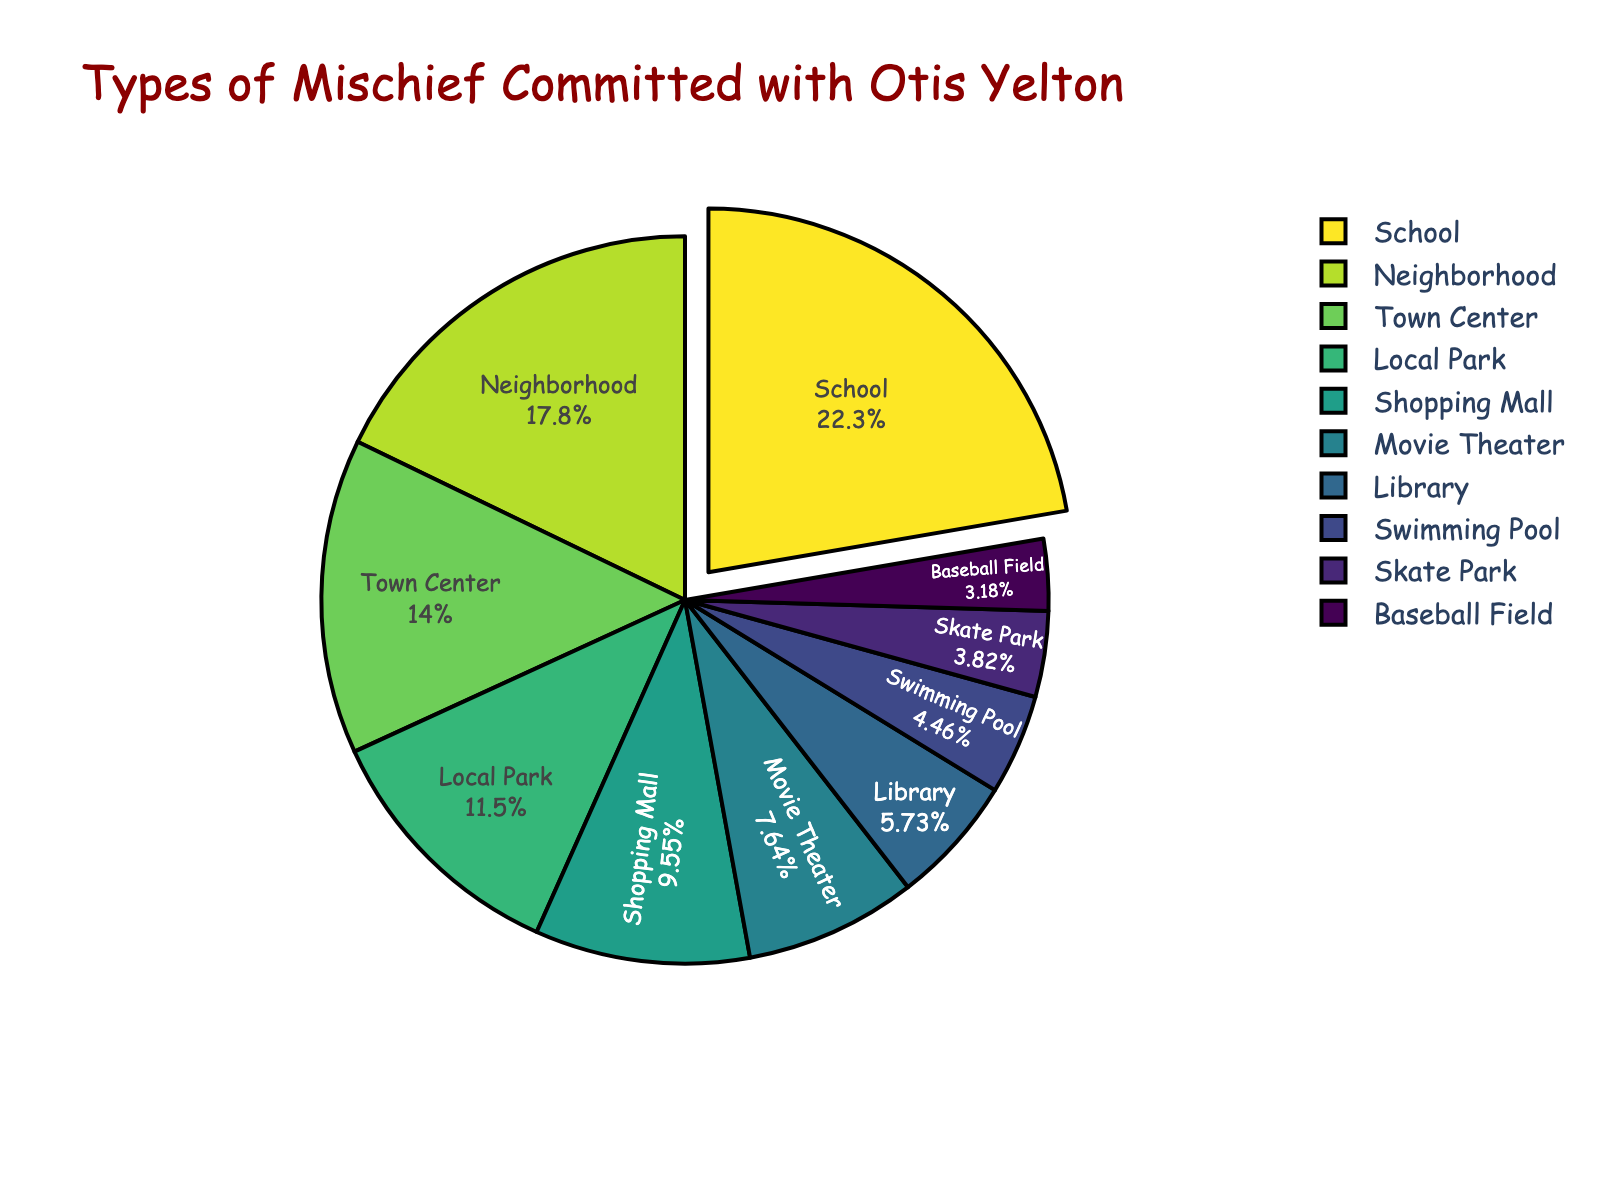Which location had the highest number of mischief incidents? By looking at the pie chart, the largest segment represents the location with the highest number of incidents. One segment is noticeably larger than the others, corresponding to the 'School'.
Answer: School How many more incidents occurred in the School compared to the Library? First, find the number of incidents at the School (35) and the Library (9). Subtract the number of Library incidents from the School incidents: 35 - 9 = 26.
Answer: 26 What percentage of the total mischief incidents occurred at the Movie Theater? Look at the pie chart segment labeled 'Movie Theater' to find its percentage. The 'Movie Theater' segment shows 7% of the total incidents.
Answer: 7% How many total incidents occurred in the top three locations? The top three locations by number of incidents are School (35), Neighborhood (28), and Town Center (22). Add these numbers together: 35 + 28 + 22 = 85.
Answer: 85 Were there more incidents at the Local Park or the Shopping Mall? By comparing the size of the segments, it's clear that the 'Local Park' segment is larger than the 'Shopping Mall'. The Local Park had 18 incidents while the Shopping Mall had 15.
Answer: Local Park What is the combined percentage of incidents at the Swimming Pool and the Skate Park? First, identify the percentages from the pie chart for the Swimming Pool (4%) and the Skate Park (3%). Then, sum these percentages: 4 + 3 = 7.
Answer: 7% Arrange the locations in decreasing order of mischief incidents. By examining the pie chart, order the locations from the biggest to the smallest segment: School (35), Neighborhood (28), Town Center (22), Local Park (18), Shopping Mall (15), Movie Theater (12), Library (9), Swimming Pool (7), Skate Park (6), Baseball Field (5).
Answer: School, Neighborhood, Town Center, Local Park, Shopping Mall, Movie Theater, Library, Swimming Pool, Skate Park, Baseball Field What is the difference in the number of incidents between the location with the highest and lowest incidents? Identify the highest number (School with 35 incidents) and the lowest (Baseball Field with 5 incidents). Subtract the lowest number from the highest: 35 - 5 = 30.
Answer: 30 